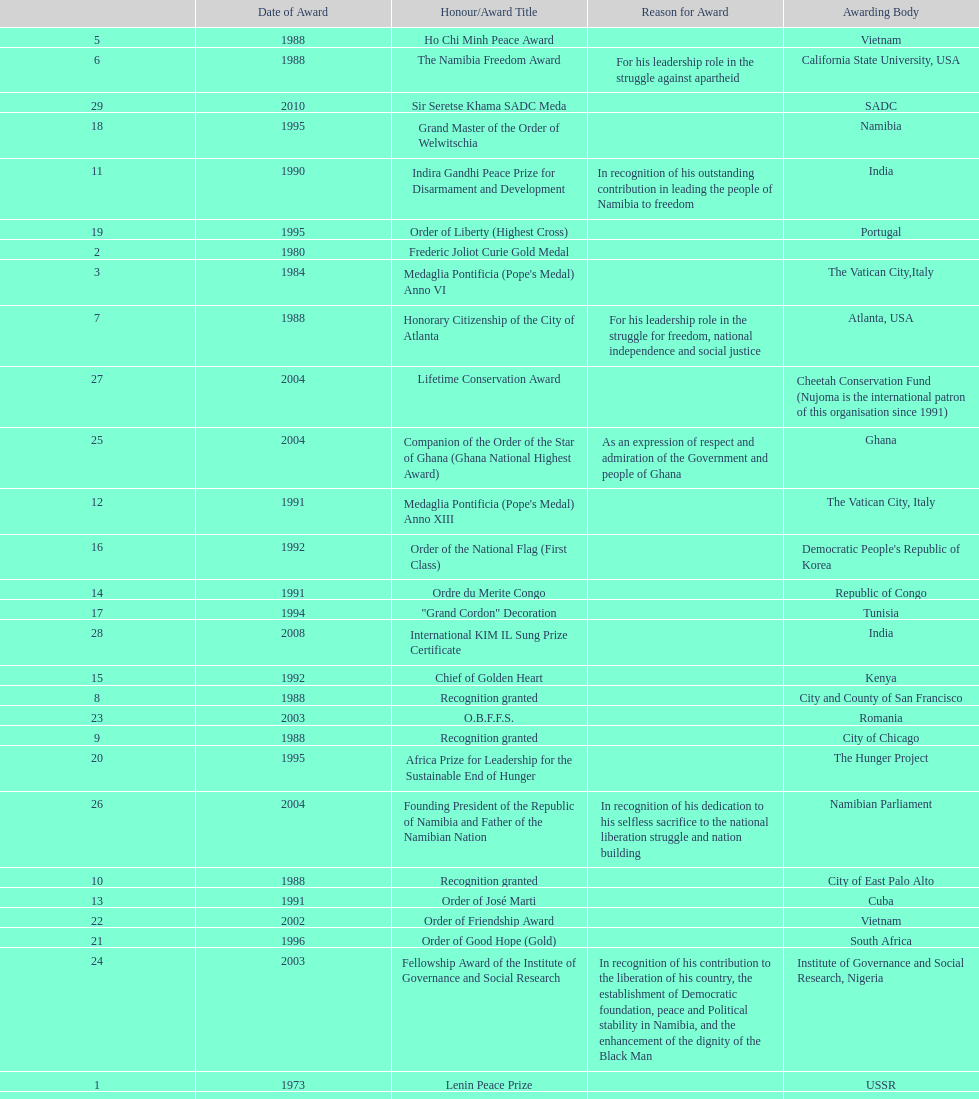What is the total number of awards that nujoma won? 29. 